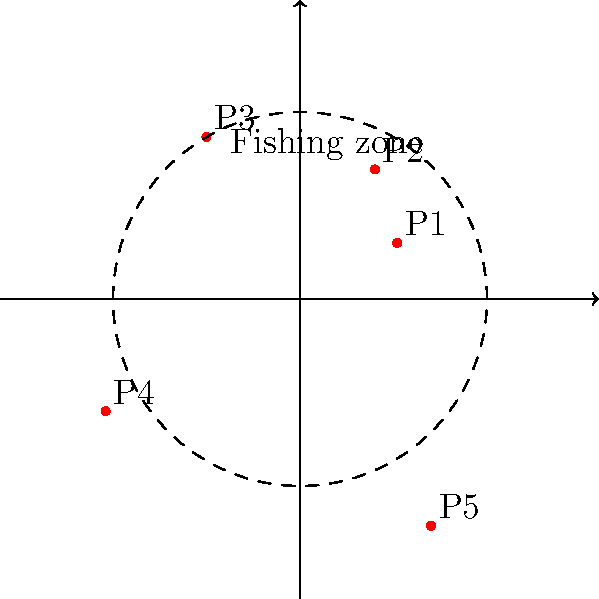The polar plot shows the locations of five offshore drilling platforms (P1 to P5) in relation to a circular fishing zone with a radius of 5 units. Which platform(s) is/are located within the fishing zone, potentially impacting marine resources? To determine which platforms are within the fishing zone, we need to compare their radial distances to the fishing zone radius of 5 units.

Step 1: Analyze each platform's radial distance:
P1: $r = 3$ (within the zone)
P2: $r = 4$ (within the zone)
P3: $r = 5$ (on the boundary)
P4: $r = 6$ (outside the zone)
P5: $r = 7$ (outside the zone)

Step 2: Identify platforms strictly within the fishing zone:
Only P1 and P2 have radial distances less than 5 units.

Step 3: Consider the impact on marine resources:
Platforms within the fishing zone (P1 and P2) are most likely to directly impact marine resources in the protected area.

Step 4: Address the platform on the boundary:
P3 is exactly on the boundary ($r = 5$). While it's not strictly inside the zone, it could still have potential impacts and might be considered in a more conservative assessment.
Answer: P1 and P2 